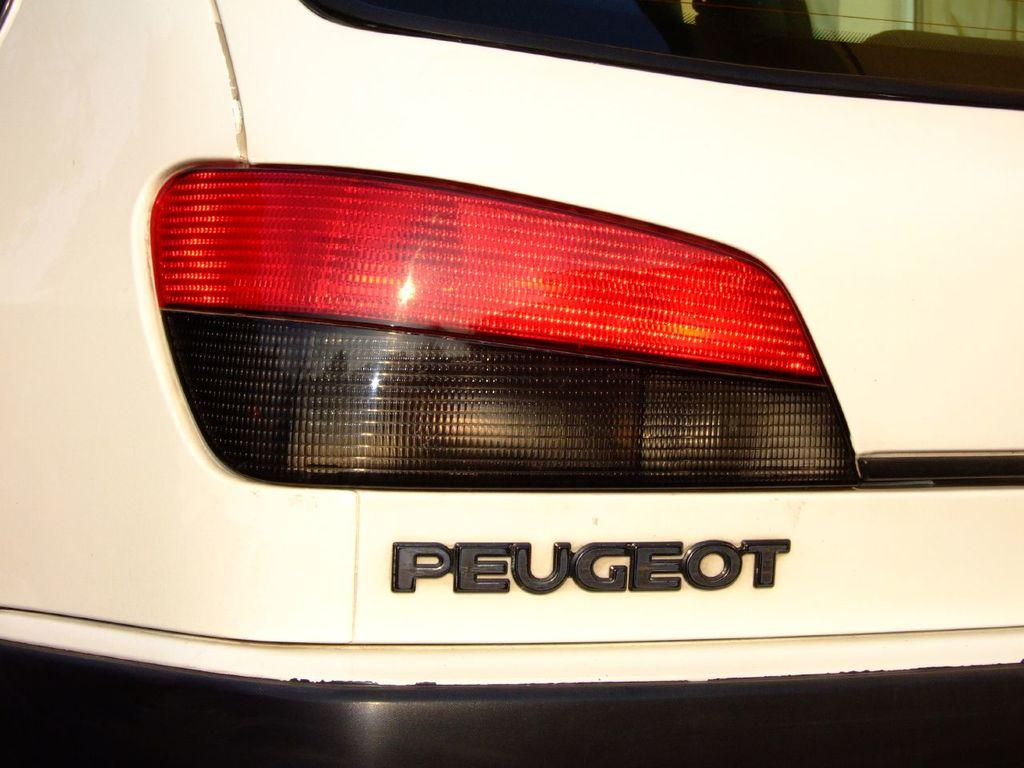What type of object is the main subject in the image? There is a vehicle in the image. What is the color of the vehicle? The vehicle is white in color. Are there any lights on the vehicle? Yes, there is a light on the vehicle. What colors make up the light on the vehicle? The light is red and black in color. Is there any text or name on the vehicle? Yes, the name is written on the vehicle. How many men are visible in the image? There are no men present in the image; it only features a vehicle with a light and a name. Is there a cat sitting on the vehicle in the image? There is no cat present in the image; it only features a vehicle with a light and a name. 